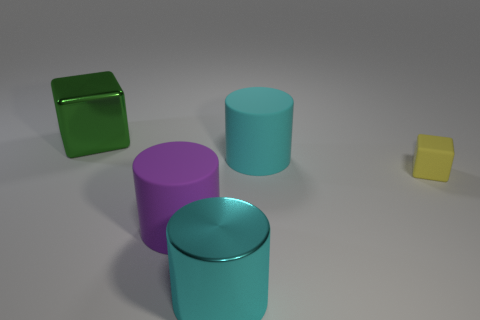What material is the other cylinder that is the same color as the shiny cylinder?
Offer a terse response. Rubber. What number of big rubber cylinders are the same color as the metal cylinder?
Offer a very short reply. 1. There is a big rubber thing to the right of the large matte cylinder in front of the small yellow cube; how many things are in front of it?
Offer a very short reply. 3. Does the large shiny object in front of the small yellow matte object have the same shape as the small yellow thing?
Keep it short and to the point. No. There is a large cyan cylinder behind the cyan shiny cylinder; what is its material?
Give a very brief answer. Rubber. What shape is the matte thing that is on the right side of the large metallic cylinder and left of the yellow object?
Your response must be concise. Cylinder. What material is the purple cylinder?
Keep it short and to the point. Rubber. What number of blocks are either big cyan things or purple rubber objects?
Provide a succinct answer. 0. Do the purple object and the large cube have the same material?
Ensure brevity in your answer.  No. The other rubber object that is the same shape as the large purple rubber thing is what size?
Your response must be concise. Large. 